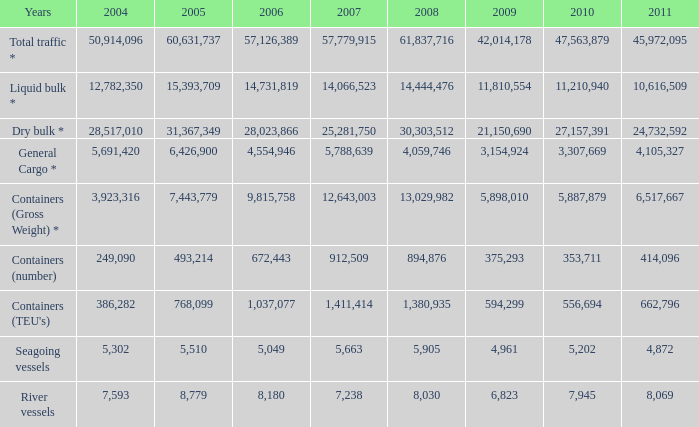In 2009, what was the combined total of years for river vessels, given that there were more than 8,030 in 2008 and over 1,411,414 in 2007? 0.0. 